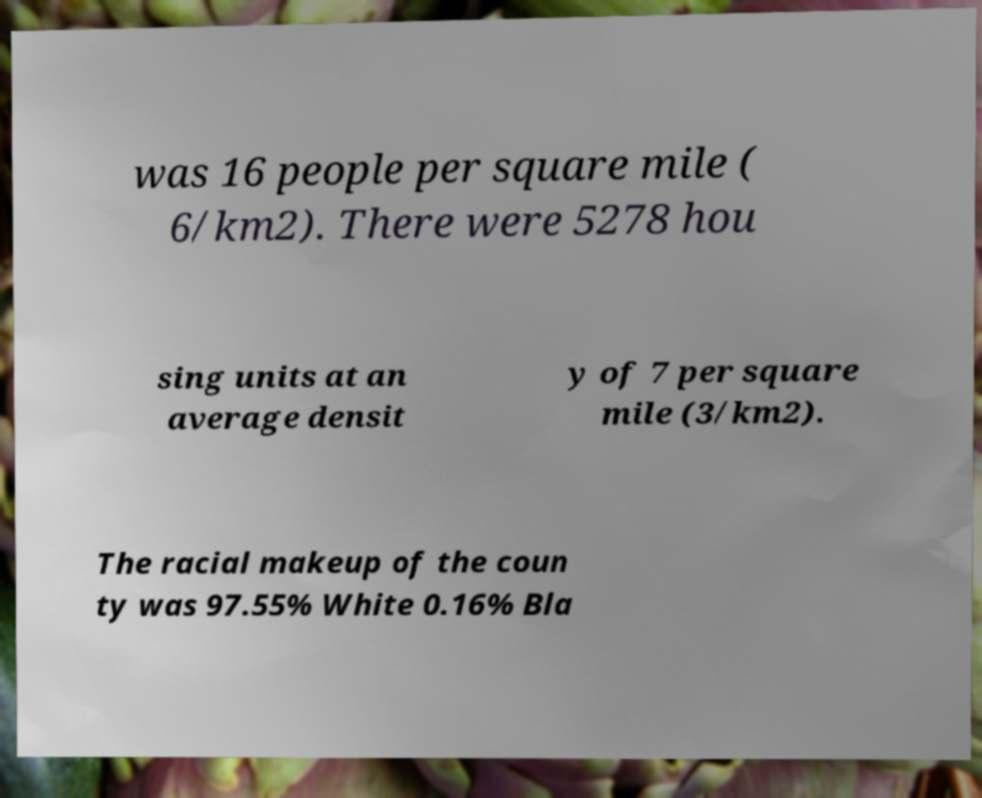Could you assist in decoding the text presented in this image and type it out clearly? was 16 people per square mile ( 6/km2). There were 5278 hou sing units at an average densit y of 7 per square mile (3/km2). The racial makeup of the coun ty was 97.55% White 0.16% Bla 